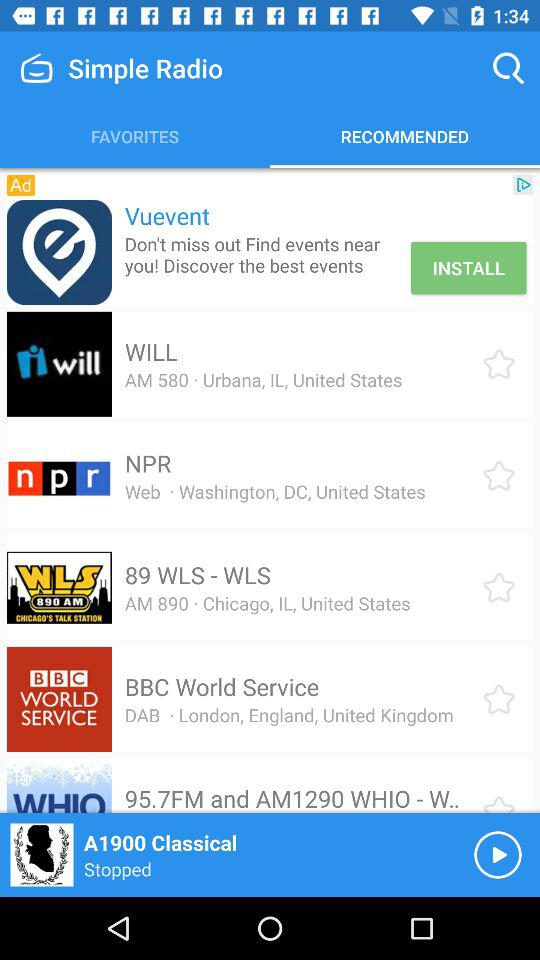What is the location of "BBC World Service"? "BBC World Service" is located in London, England, in the United Kingdom. 